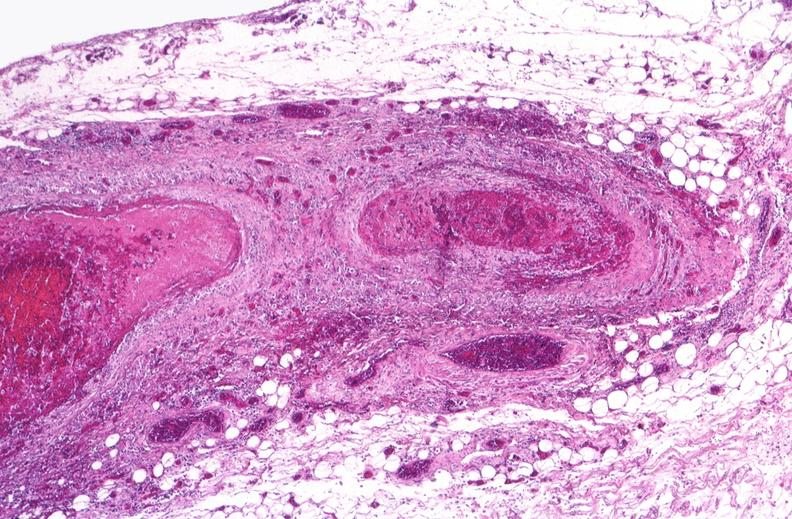what does this image show?
Answer the question using a single word or phrase. Polyarteritis nodosa 